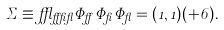<formula> <loc_0><loc_0><loc_500><loc_500>\Sigma \equiv \epsilon _ { \alpha \beta \gamma } \Phi _ { \alpha } \Phi _ { \beta } \Phi _ { \gamma } = ( 1 , 1 ) ( + 6 ) .</formula> 